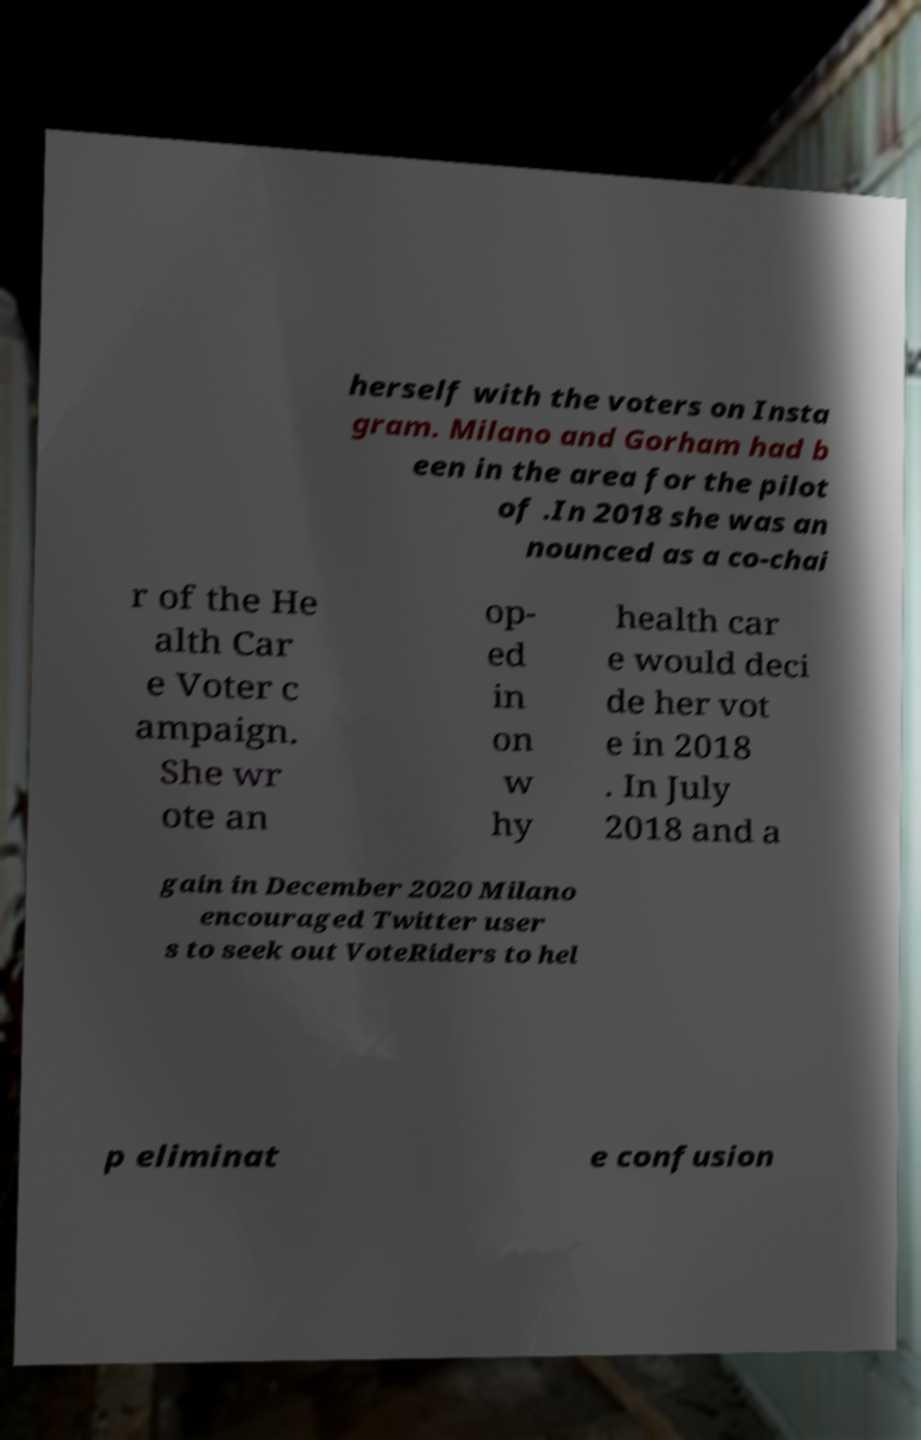Can you accurately transcribe the text from the provided image for me? herself with the voters on Insta gram. Milano and Gorham had b een in the area for the pilot of .In 2018 she was an nounced as a co-chai r of the He alth Car e Voter c ampaign. She wr ote an op- ed in on w hy health car e would deci de her vot e in 2018 . In July 2018 and a gain in December 2020 Milano encouraged Twitter user s to seek out VoteRiders to hel p eliminat e confusion 